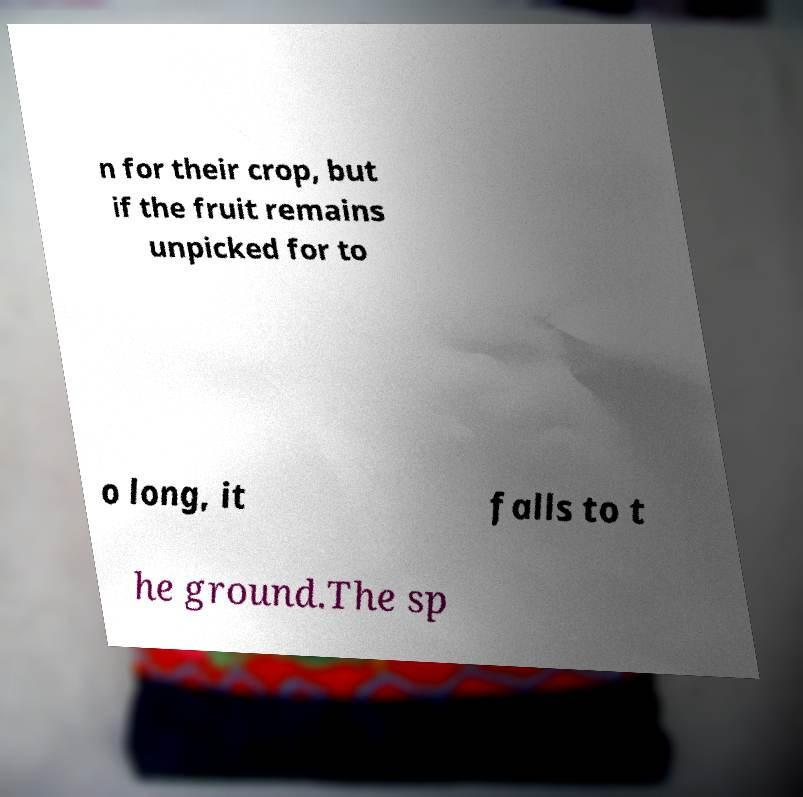Can you accurately transcribe the text from the provided image for me? n for their crop, but if the fruit remains unpicked for to o long, it falls to t he ground.The sp 